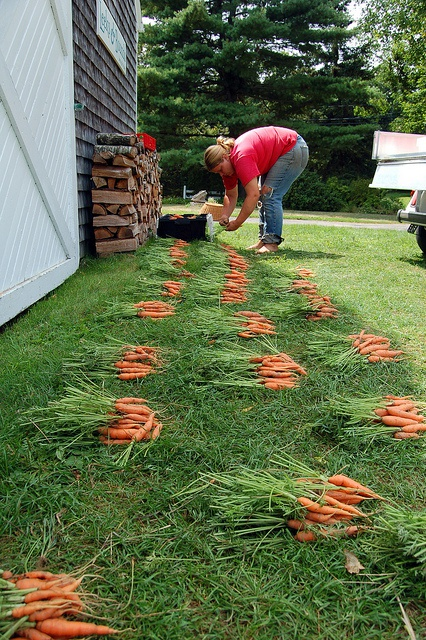Describe the objects in this image and their specific colors. I can see carrot in darkgray, tan, darkgreen, brown, and olive tones, people in darkgray, gray, maroon, black, and brown tones, truck in darkgray, white, black, and gray tones, carrot in darkgray, tan, and olive tones, and carrot in darkgray, tan, brown, and red tones in this image. 